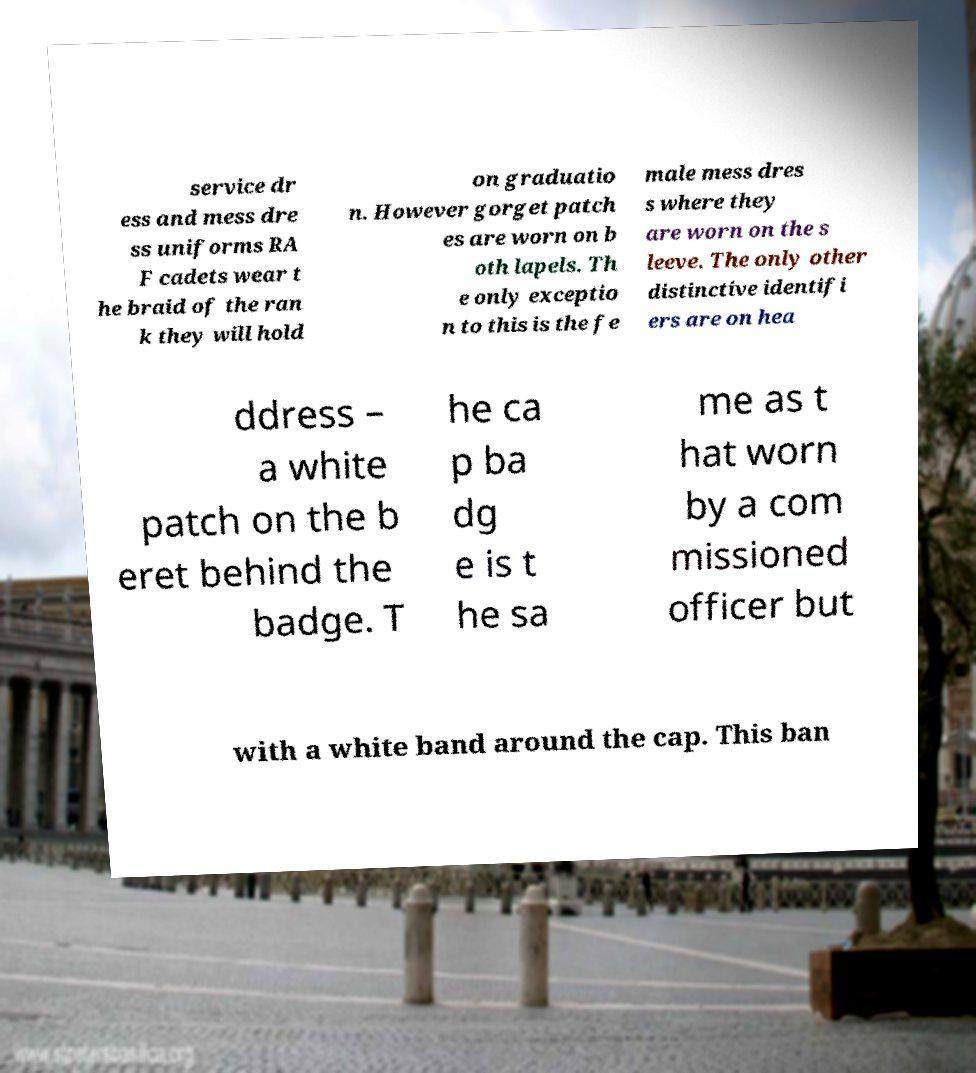There's text embedded in this image that I need extracted. Can you transcribe it verbatim? service dr ess and mess dre ss uniforms RA F cadets wear t he braid of the ran k they will hold on graduatio n. However gorget patch es are worn on b oth lapels. Th e only exceptio n to this is the fe male mess dres s where they are worn on the s leeve. The only other distinctive identifi ers are on hea ddress – a white patch on the b eret behind the badge. T he ca p ba dg e is t he sa me as t hat worn by a com missioned officer but with a white band around the cap. This ban 